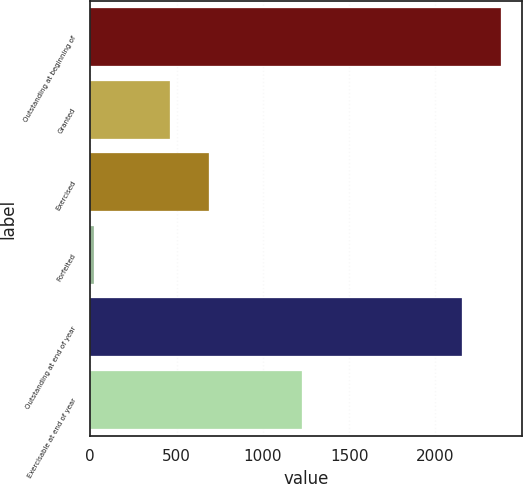<chart> <loc_0><loc_0><loc_500><loc_500><bar_chart><fcel>Outstanding at beginning of<fcel>Granted<fcel>Exercised<fcel>Forfeited<fcel>Outstanding at end of year<fcel>Exercisable at end of year<nl><fcel>2380.8<fcel>464<fcel>690.8<fcel>19<fcel>2154<fcel>1229<nl></chart> 